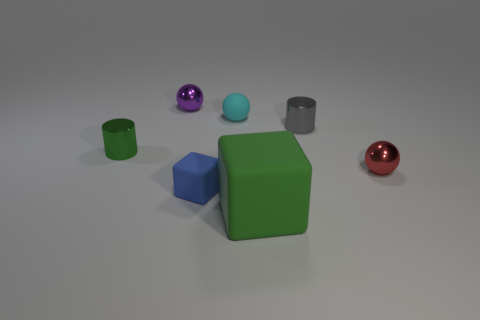Are there any other things that are the same size as the green matte cube?
Offer a terse response. No. How many metallic things are blue things or brown things?
Your answer should be compact. 0. What number of things are on the left side of the blue object and behind the gray metallic cylinder?
Provide a succinct answer. 1. Is there anything else that has the same shape as the small gray object?
Give a very brief answer. Yes. How many other things are the same size as the green matte thing?
Give a very brief answer. 0. Does the metal sphere behind the green cylinder have the same size as the cylinder that is to the right of the large rubber object?
Provide a short and direct response. Yes. What number of things are metal blocks or metal spheres behind the green cylinder?
Offer a terse response. 1. What is the size of the green thing that is on the left side of the small blue object?
Ensure brevity in your answer.  Small. Is the number of small blue matte blocks to the left of the small blue rubber cube less than the number of small objects that are right of the big green matte cube?
Your response must be concise. Yes. What is the object that is both behind the small green shiny cylinder and in front of the cyan rubber thing made of?
Your response must be concise. Metal. 